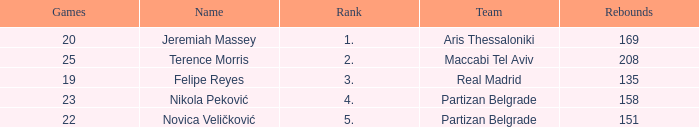What is the number of Games for Partizan Belgrade player Nikola Peković with a Rank of more than 4? None. 